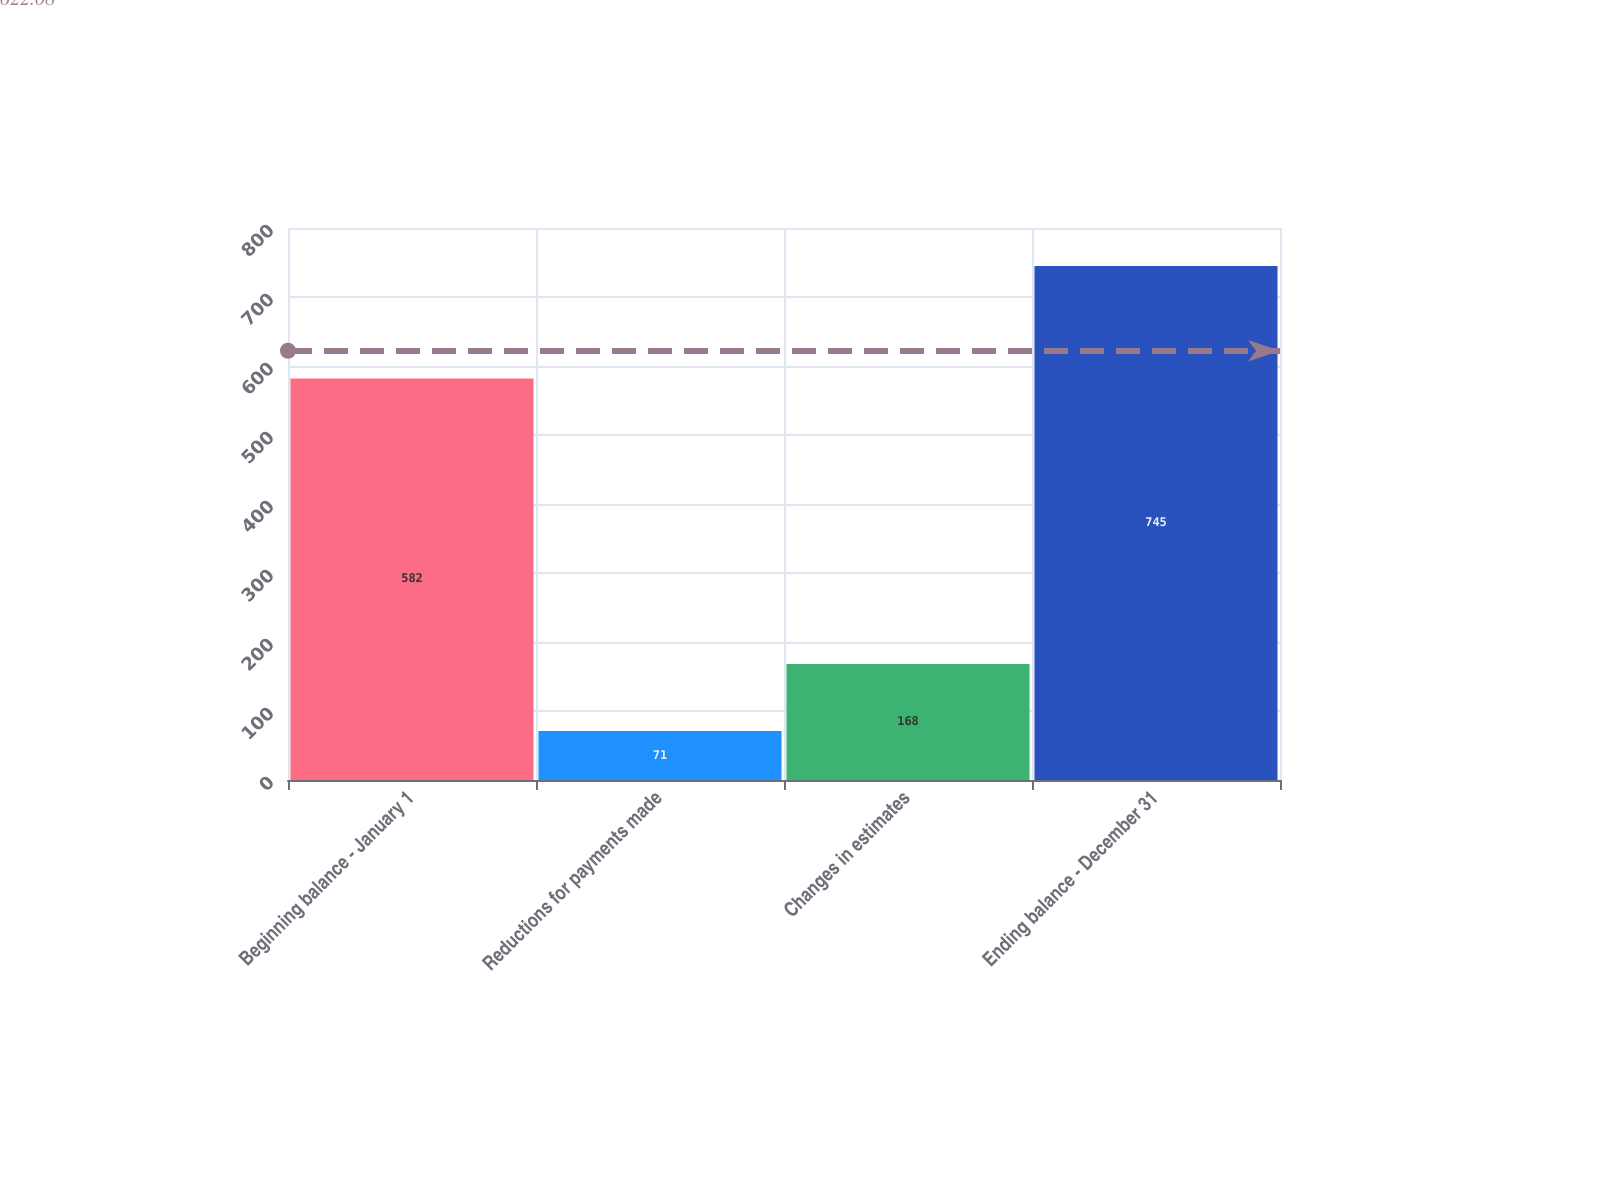<chart> <loc_0><loc_0><loc_500><loc_500><bar_chart><fcel>Beginning balance - January 1<fcel>Reductions for payments made<fcel>Changes in estimates<fcel>Ending balance - December 31<nl><fcel>582<fcel>71<fcel>168<fcel>745<nl></chart> 